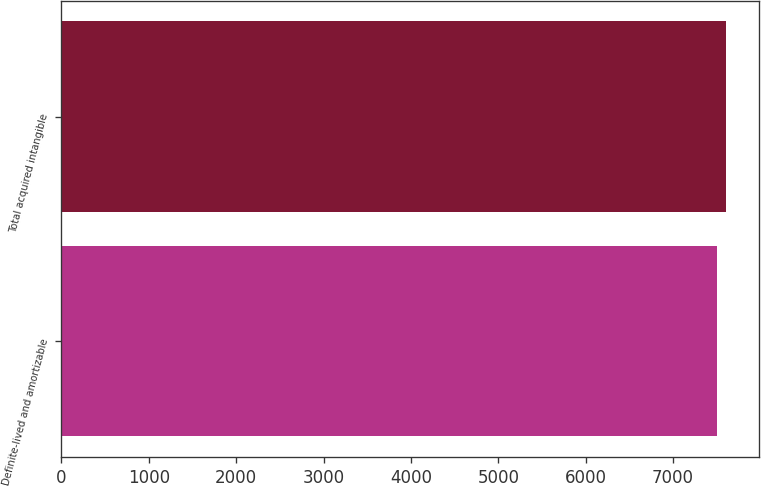Convert chart. <chart><loc_0><loc_0><loc_500><loc_500><bar_chart><fcel>Definite-lived and amortizable<fcel>Total acquired intangible<nl><fcel>7507<fcel>7607<nl></chart> 